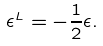<formula> <loc_0><loc_0><loc_500><loc_500>\epsilon ^ { L } = - \frac { 1 } { 2 } \epsilon .</formula> 